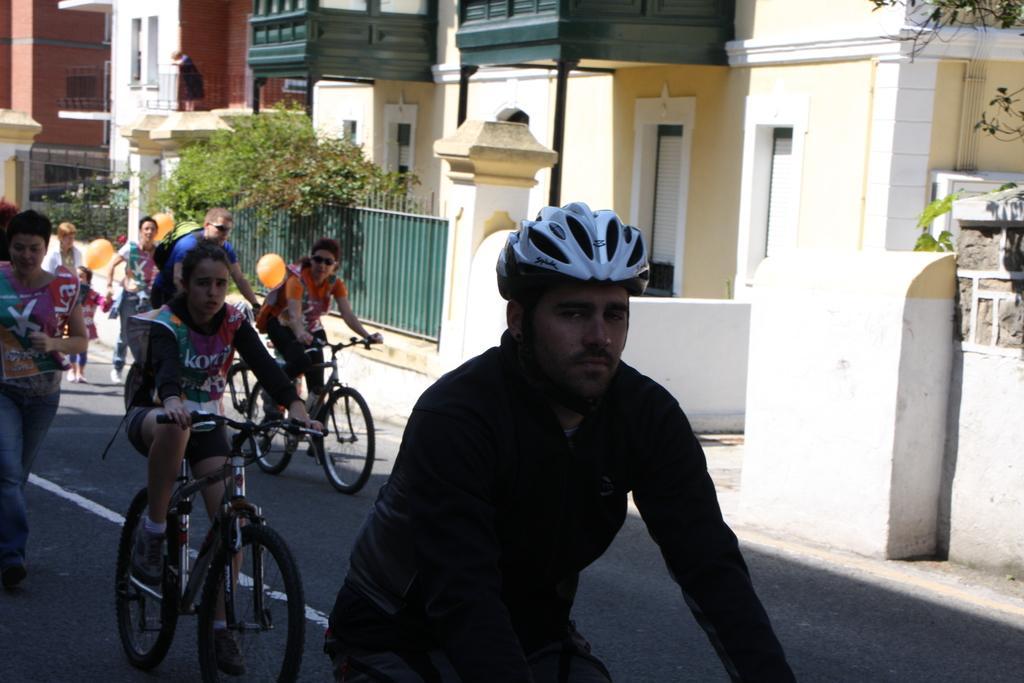Describe this image in one or two sentences. In this picture there is a man riding a bicycle, wearing a helmet. In the background there are some people walking and riding bicycles on the road. We can observe a gate, trees and a buildings here. 